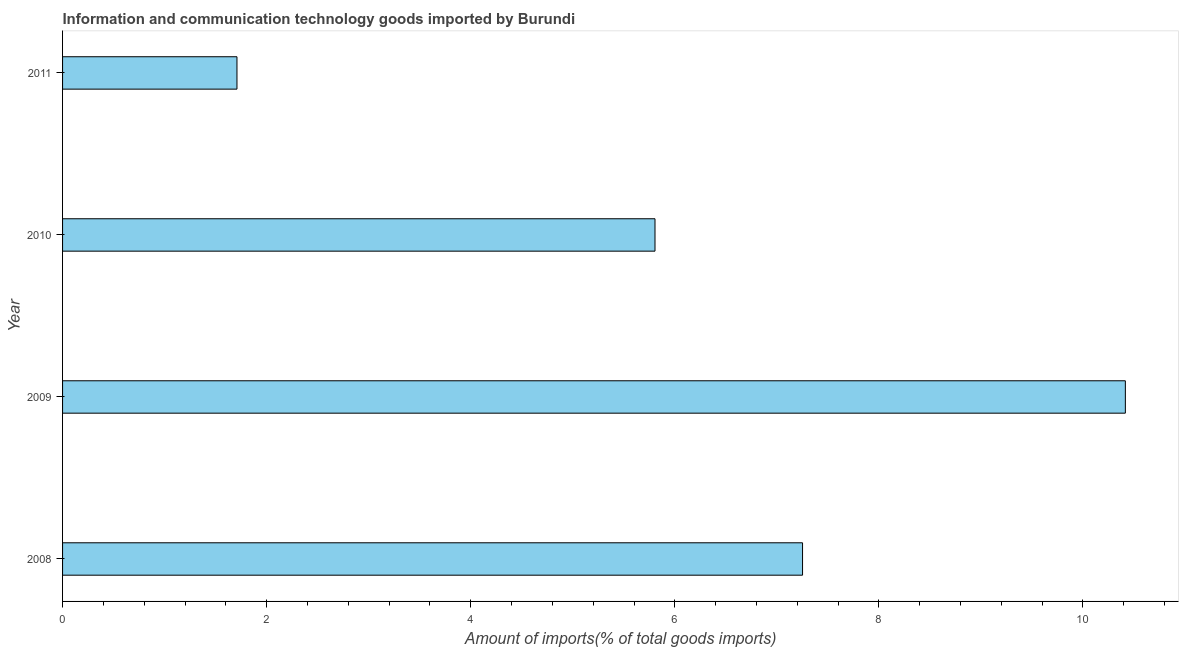Does the graph contain grids?
Your answer should be very brief. No. What is the title of the graph?
Give a very brief answer. Information and communication technology goods imported by Burundi. What is the label or title of the X-axis?
Offer a very short reply. Amount of imports(% of total goods imports). What is the label or title of the Y-axis?
Provide a succinct answer. Year. What is the amount of ict goods imports in 2008?
Make the answer very short. 7.25. Across all years, what is the maximum amount of ict goods imports?
Provide a short and direct response. 10.42. Across all years, what is the minimum amount of ict goods imports?
Make the answer very short. 1.71. In which year was the amount of ict goods imports maximum?
Ensure brevity in your answer.  2009. What is the sum of the amount of ict goods imports?
Provide a succinct answer. 25.18. What is the difference between the amount of ict goods imports in 2009 and 2011?
Provide a short and direct response. 8.71. What is the average amount of ict goods imports per year?
Ensure brevity in your answer.  6.29. What is the median amount of ict goods imports?
Offer a terse response. 6.53. Do a majority of the years between 2008 and 2011 (inclusive) have amount of ict goods imports greater than 6 %?
Give a very brief answer. No. What is the ratio of the amount of ict goods imports in 2008 to that in 2011?
Give a very brief answer. 4.24. Is the difference between the amount of ict goods imports in 2008 and 2010 greater than the difference between any two years?
Your answer should be very brief. No. What is the difference between the highest and the second highest amount of ict goods imports?
Make the answer very short. 3.16. What is the difference between the highest and the lowest amount of ict goods imports?
Ensure brevity in your answer.  8.71. How many years are there in the graph?
Offer a terse response. 4. What is the Amount of imports(% of total goods imports) of 2008?
Provide a short and direct response. 7.25. What is the Amount of imports(% of total goods imports) in 2009?
Ensure brevity in your answer.  10.42. What is the Amount of imports(% of total goods imports) in 2010?
Your response must be concise. 5.81. What is the Amount of imports(% of total goods imports) in 2011?
Provide a short and direct response. 1.71. What is the difference between the Amount of imports(% of total goods imports) in 2008 and 2009?
Offer a terse response. -3.16. What is the difference between the Amount of imports(% of total goods imports) in 2008 and 2010?
Your response must be concise. 1.45. What is the difference between the Amount of imports(% of total goods imports) in 2008 and 2011?
Offer a very short reply. 5.54. What is the difference between the Amount of imports(% of total goods imports) in 2009 and 2010?
Keep it short and to the point. 4.61. What is the difference between the Amount of imports(% of total goods imports) in 2009 and 2011?
Your answer should be compact. 8.71. What is the difference between the Amount of imports(% of total goods imports) in 2010 and 2011?
Your response must be concise. 4.1. What is the ratio of the Amount of imports(% of total goods imports) in 2008 to that in 2009?
Ensure brevity in your answer.  0.7. What is the ratio of the Amount of imports(% of total goods imports) in 2008 to that in 2010?
Your response must be concise. 1.25. What is the ratio of the Amount of imports(% of total goods imports) in 2008 to that in 2011?
Offer a very short reply. 4.24. What is the ratio of the Amount of imports(% of total goods imports) in 2009 to that in 2010?
Your answer should be very brief. 1.79. What is the ratio of the Amount of imports(% of total goods imports) in 2009 to that in 2011?
Your response must be concise. 6.09. What is the ratio of the Amount of imports(% of total goods imports) in 2010 to that in 2011?
Offer a very short reply. 3.4. 